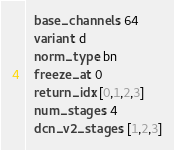Convert code to text. <code><loc_0><loc_0><loc_500><loc_500><_YAML_>  base_channels: 64
  variant: d
  norm_type: bn
  freeze_at: 0
  return_idx: [0,1,2,3]
  num_stages: 4
  dcn_v2_stages: [1,2,3]
</code> 